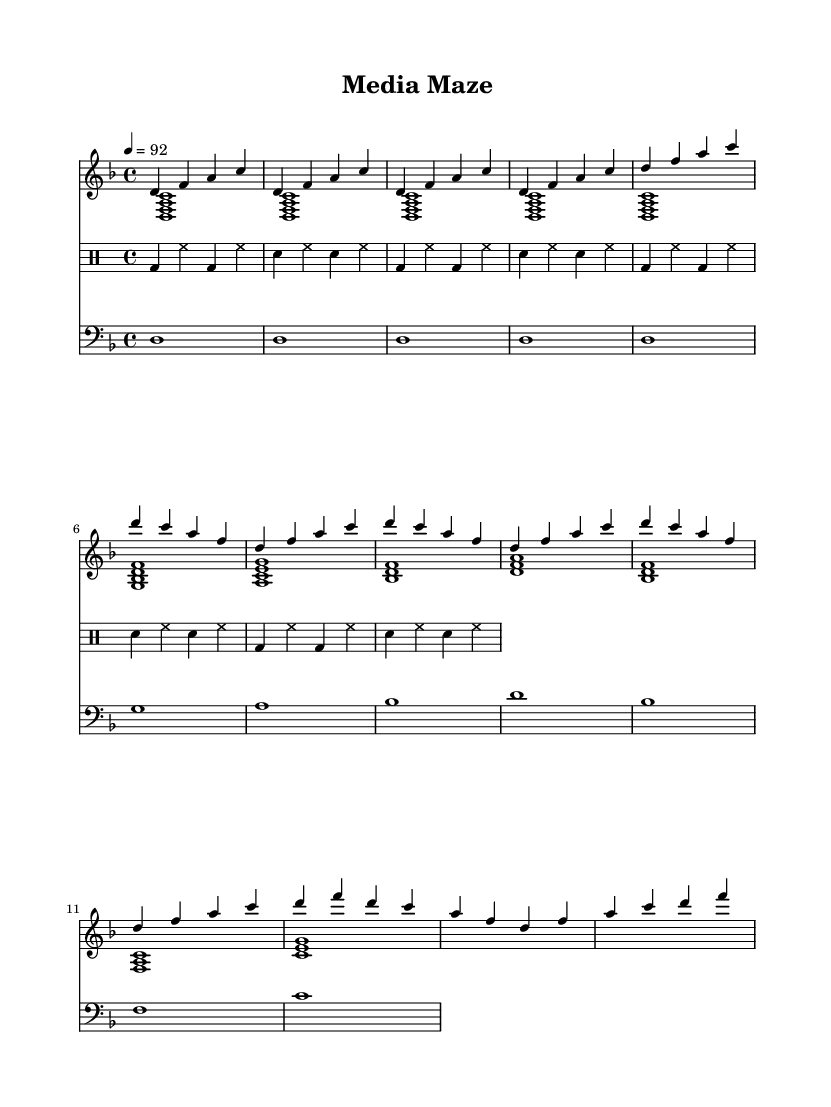What is the key signature of this music? The key signature is D minor, which consists of one flat (B♭).
Answer: D minor What is the time signature of this music? The time signature is 4/4, indicating four beats in each measure.
Answer: 4/4 What is the tempo mark of this music? The tempo is marked at quarter note equals 92 beats per minute.
Answer: 92 How many measures are in the intro section of the music? The intro is repeated four times, so it comprises four measures.
Answer: 4 In the verse section, how many unique pitches are used? The pitches used in the verse include D, F, A, C, G, and B♭, totaling six unique pitches.
Answer: 6 What rhythmic pattern do the drums follow during the intro? The drum pattern consists of a kick drum followed by a hi-hat pattern repeated four times.
Answer: Kick drum and hi-hat Which section of the music has the same chord progression as the choruses? Both the introduction and the chorus share similar chord progressions, specifically the same bass notes.
Answer: Introduction 